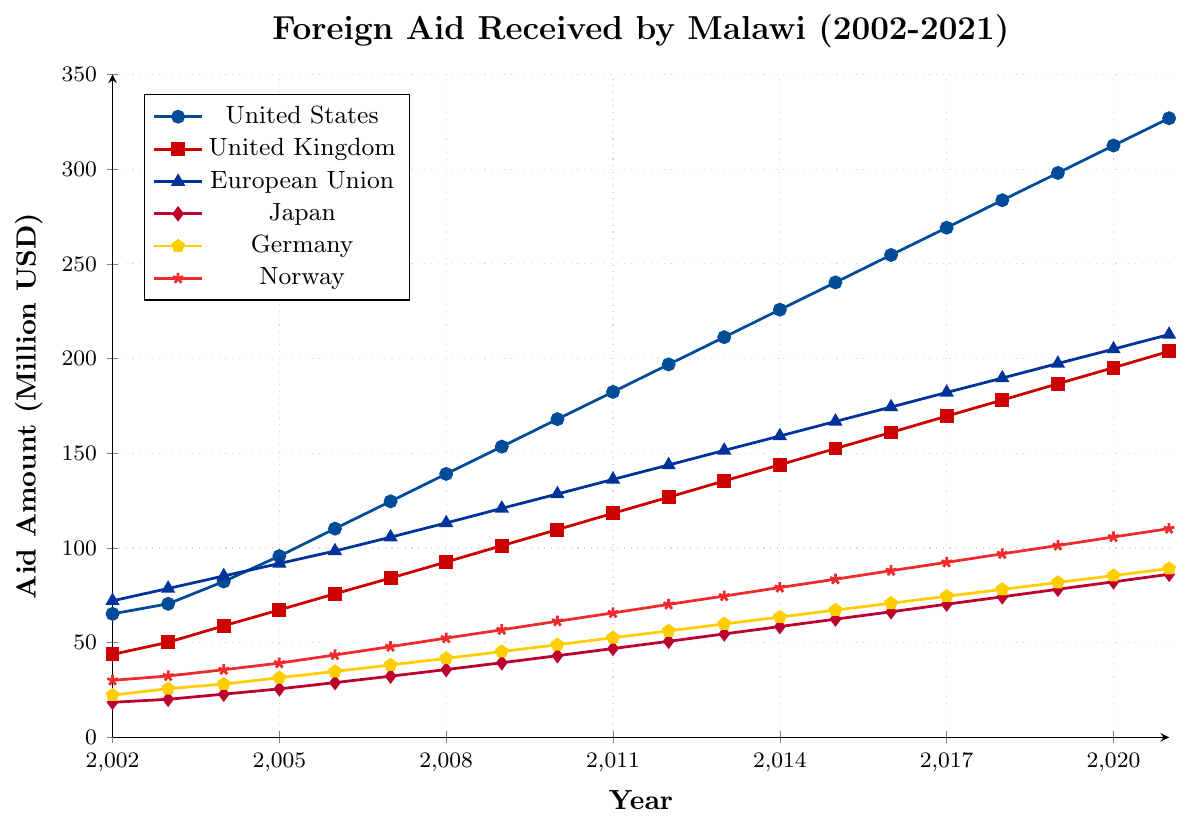Which donor country provided the highest amount of foreign aid to Malawi in 2010? According to the figure, the United States provided the highest amount of foreign aid to Malawi in 2010, reaching 168 million USD.
Answer: United States Between 2005 and 2010, which donor country showed the greatest increase in foreign aid provided to Malawi? Comparing the increase from 2005 to 2010 for each country: United States (95.7 to 168.0), United Kingdom (67.3 to 109.7), European Union (91.8 to 128.5), Japan (25.6 to 43.1), Germany (31.5 to 48.9), Norway (39.2 to 61.3). The United States showed the greatest increase (168.0 - 95.7 = 72.3 million USD).
Answer: United States What was the total amount of foreign aid received by Malawi from all donor countries in 2015? Adding the aid amounts from each donor country in 2015: United States (240.2), United Kingdom (152.5), European Union (166.8), Japan (62.4), Germany (67.2), Norway (83.5). The total is 240.2 + 152.5 + 166.8 + 62.4 + 67.2 + 83.5 = 772.6 million USD.
Answer: 772.6 million USD Which country had the smallest increase in foreign aid to Malawi between 2015 and 2021? Comparing the foreign aid amounts in 2015 and 2021 for all donor countries: United States (240.2 to 326.9), United Kingdom (152.5 to 203.8), European Union (166.8 to 212.7), Japan (62.4 to 86.1), Germany (67.2 to 89.1), Norway (83.5 to 110.2). The smallest increase is observed for Germany (89.1 - 67.2 = 21.9 million USD).
Answer: Germany By how much did the foreign aid from Norway to Malawi increase from 2002 to 2021? Norway's foreign aid in 2002 was 30.1 million USD, and in 2021, it was 110.2 million USD. The increase is 110.2 - 30.1 = 80.1 million USD.
Answer: 80.1 million USD Considering only the data from 2010 to 2021, which donor country had the most consistent increase in foreign aid to Malawi each year? Looking at the aid figures from 2010 to 2021 for each country, we should compare the consistency in year-by-year increases for each donor. By visual inspection and the consistent stepping of the increments, the United States shows the most consistent increase in aid each year over this period.
Answer: United States Which donor country contributed a total of more than 2 billion USD in aid over the full 20 years from 2002 to 2021? Calculating the sum of the aid amounts given by each country from 2002 to 2021: 
United States contributes much more as it consistently has high values. Summing these gives a value surpassing 2 billion USD.
Answer: United States 